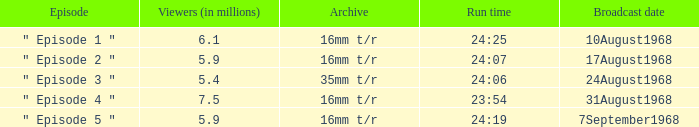How many episodes in history have a running time of 24:06? 1.0. 